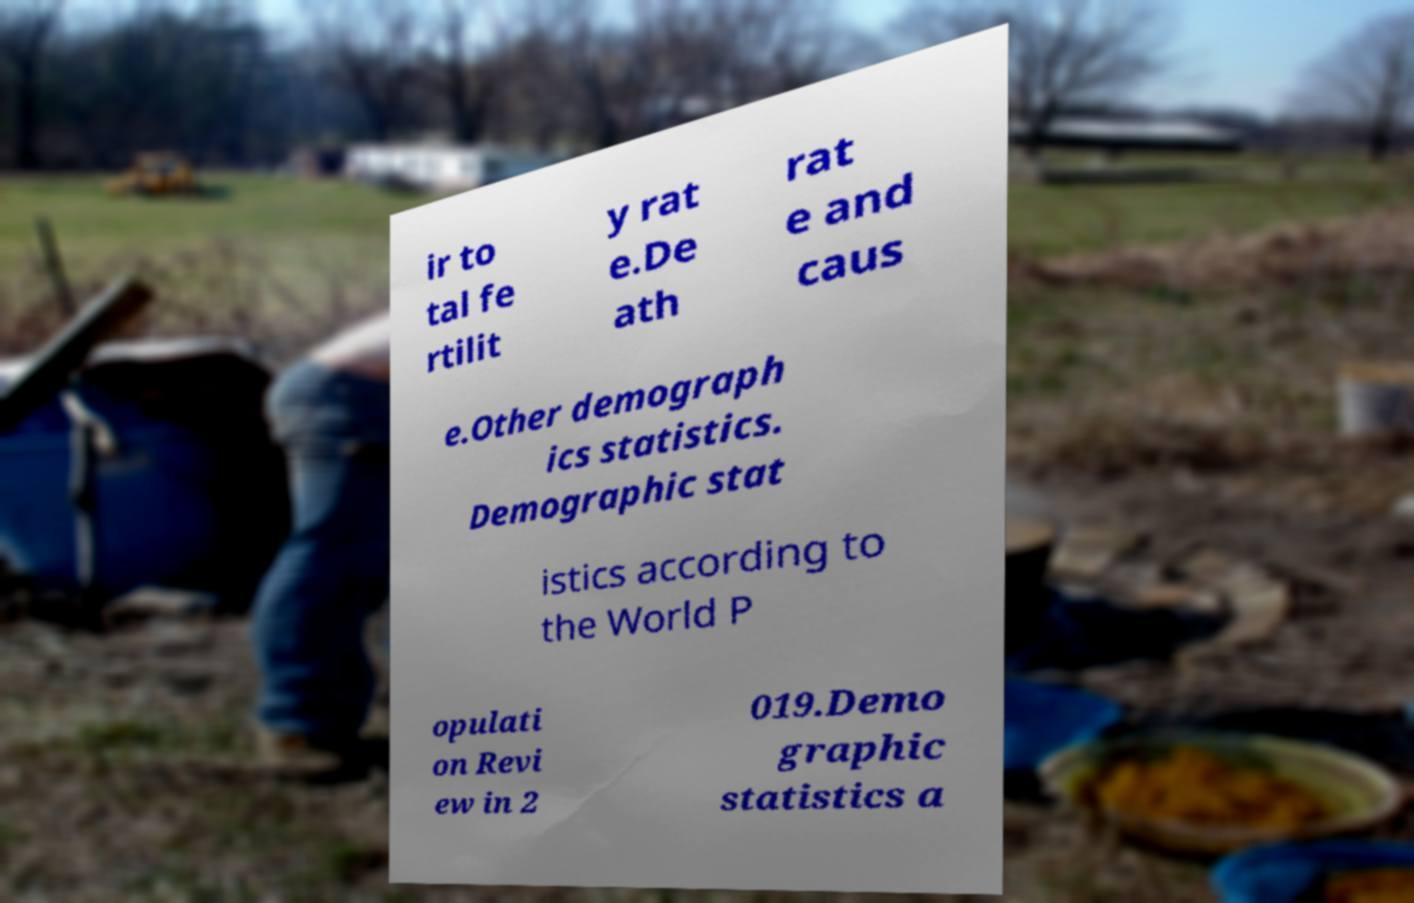Please read and relay the text visible in this image. What does it say? ir to tal fe rtilit y rat e.De ath rat e and caus e.Other demograph ics statistics. Demographic stat istics according to the World P opulati on Revi ew in 2 019.Demo graphic statistics a 